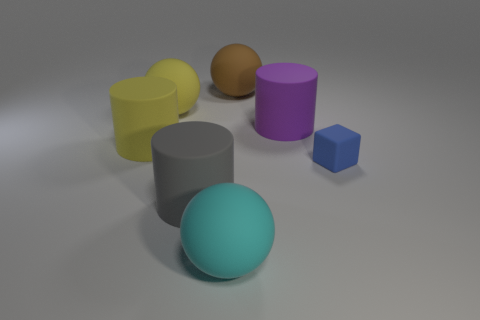How many other things are the same shape as the tiny thing?
Offer a very short reply. 0. Are the yellow sphere and the purple cylinder made of the same material?
Make the answer very short. Yes. There is a large ball that is both left of the large brown object and behind the matte cube; what is its material?
Your answer should be compact. Rubber. There is a matte sphere that is in front of the cube; what is its color?
Provide a short and direct response. Cyan. Is the number of cyan objects that are right of the small blue matte object greater than the number of large yellow rubber cylinders?
Your answer should be compact. No. How many other things are there of the same size as the brown sphere?
Your answer should be compact. 5. There is a gray rubber cylinder; what number of large brown rubber things are in front of it?
Offer a terse response. 0. Are there an equal number of big rubber balls that are in front of the big purple cylinder and blue objects to the left of the big brown matte ball?
Keep it short and to the point. No. What is the size of the yellow rubber thing that is the same shape as the large cyan thing?
Make the answer very short. Large. There is a big purple object that is on the right side of the brown ball; what is its shape?
Offer a terse response. Cylinder. 